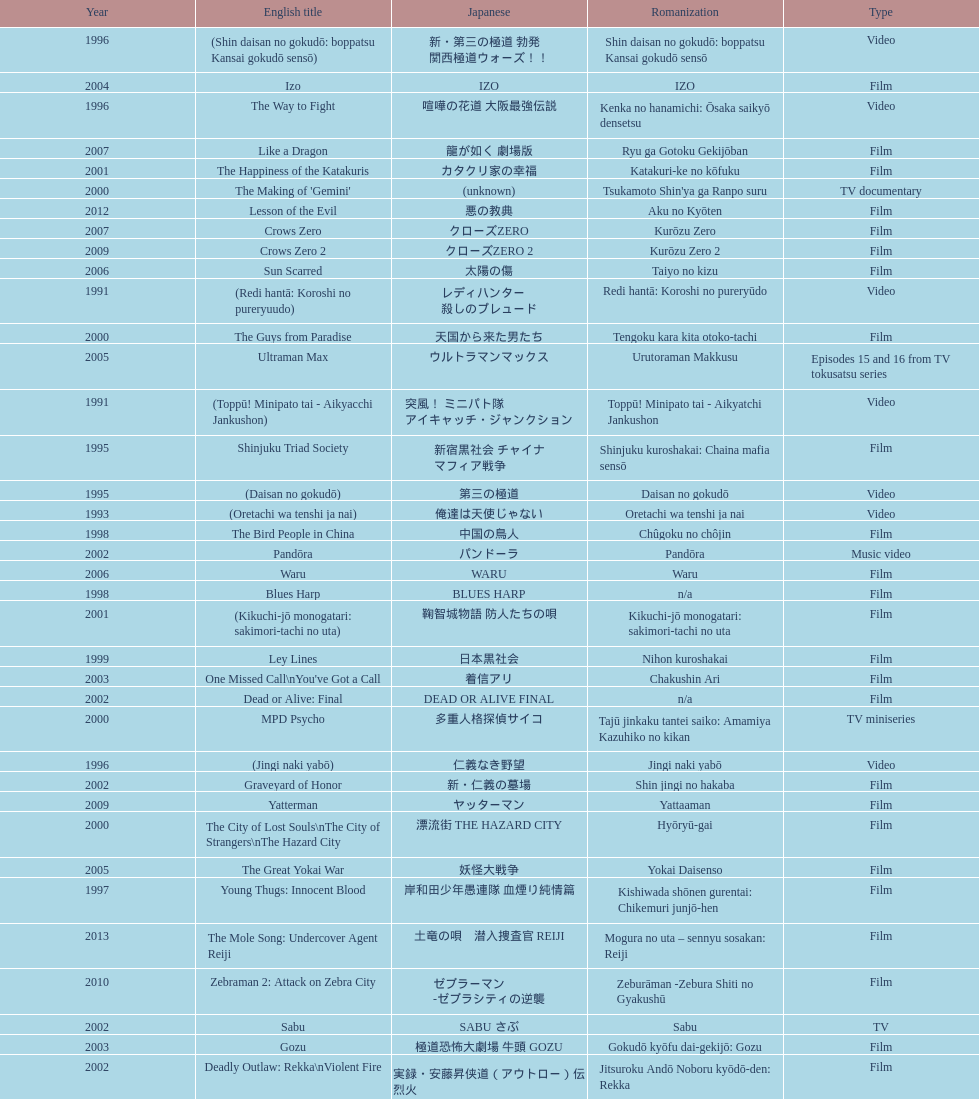Which title is listed next after "the way to fight"? Fudoh: The New Generation. 